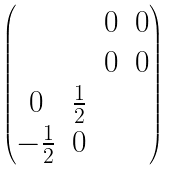<formula> <loc_0><loc_0><loc_500><loc_500>\begin{pmatrix} & & 0 & 0 \\ & & 0 & 0 \\ 0 & \frac { 1 } { 2 } & & \\ - \frac { 1 } { 2 } & 0 & & \end{pmatrix}</formula> 